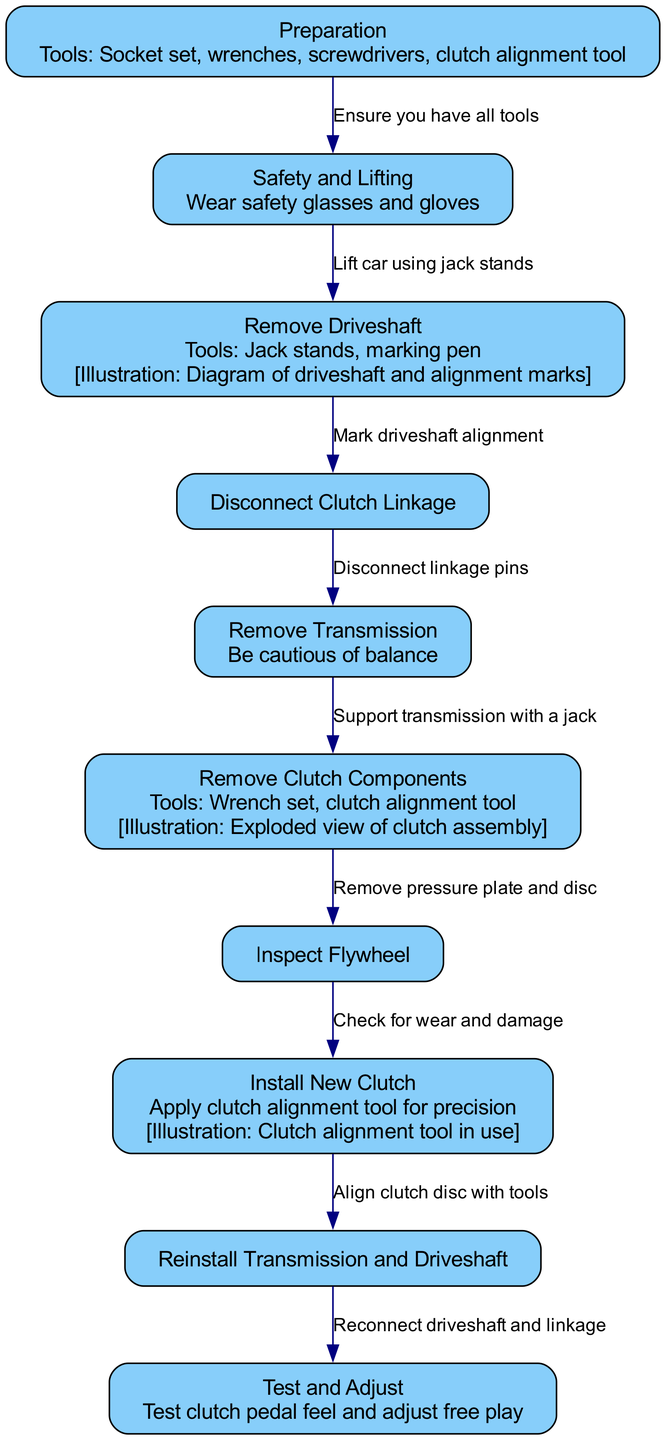What's the title of the diagram? The title is clearly indicated at the top of the diagram, and it states "Step-by-Step Clutch Replacement Process in a 1960s Muscle Car".
Answer: Step-by-Step Clutch Replacement Process in a 1960s Muscle Car How many nodes are present in the diagram? Counting each of the nodes listed in the diagram gives a total of ten; they include preparation, safety and lifting, remove driveshaft, disconnect clutch linkage, remove transmission, remove clutch components, inspect flywheel, install new clutch, reinstall transmission and driveshaft, and test and adjust.
Answer: 10 What is the first step in the clutch replacement process? The first step listed in the diagram is "Preparation", which indicates the initial phase before beginning the replacement.
Answer: Preparation Which tool is specifically mentioned for use in the 'Preparation' step? In the preparation step, the tools required are specified in the notes, which mention "Socket set, wrenches, screwdrivers, clutch alignment tool".
Answer: Socket set, wrenches, screwdrivers, clutch alignment tool What must you do before removing the driveshaft? The diagram indicates that before removing the driveshaft, you should mark the driveshaft alignment, which is crucial for proper reinstallation.
Answer: Mark driveshaft alignment What happens after removing the clutch components? After removing the clutch components, the next step according to the diagram is to inspect the flywheel for wear and damage, indicating a thorough assessment is required before proceeding.
Answer: Inspect Flywheel What is the final step in the process outlined by the diagram? The last step in the process is "Test and Adjust", which involves checking the functionality of the newly installed clutch.
Answer: Test and Adjust What tool should be applied during the 'Install New Clutch' step? During the installation of the new clutch, it is critical to apply the "clutch alignment tool for precision", as noted in the step.
Answer: Clutch alignment tool How many edges connect the nodes in the diagram? Analyzing the connections between the nodes, there are nine edges connecting them, representing the transitions between each step in the process.
Answer: 9 What safety measure should be followed during the lifting step? The diagram explicitly states that you should wear "safety glasses and gloves" to ensure proper safety while lifting the vehicle.
Answer: Wear safety glasses and gloves 